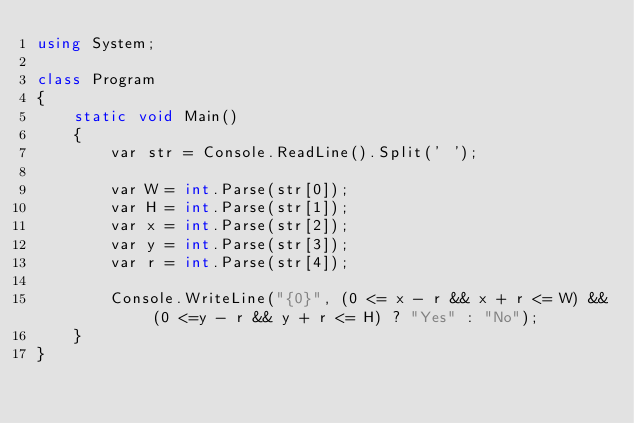Convert code to text. <code><loc_0><loc_0><loc_500><loc_500><_C#_>using System;

class Program
{
    static void Main()
    {
        var str = Console.ReadLine().Split(' ');

        var W = int.Parse(str[0]);
        var H = int.Parse(str[1]);
        var x = int.Parse(str[2]);
        var y = int.Parse(str[3]);
        var r = int.Parse(str[4]);

        Console.WriteLine("{0}", (0 <= x - r && x + r <= W) && (0 <=y - r && y + r <= H) ? "Yes" : "No");
    }
}
</code> 